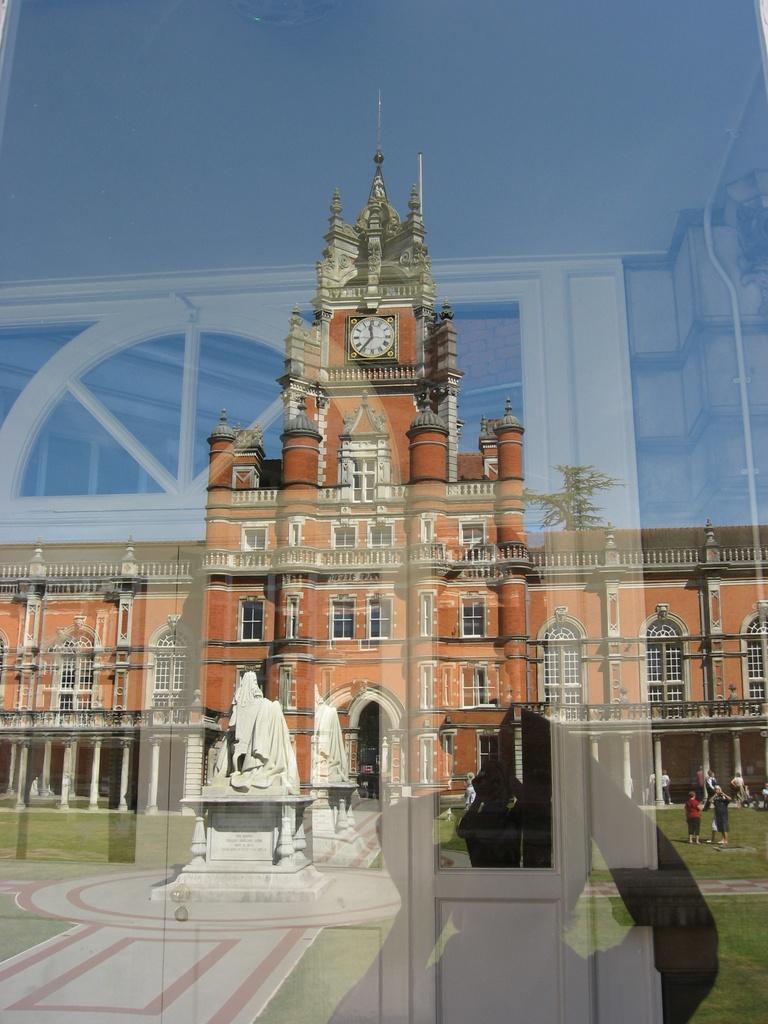How would you summarize this image in a sentence or two? In the image we can see a glass, on the glass we can see shadow and window. Through the glass we can see a statue and building and few people are standing. Behind the building there is sky. 